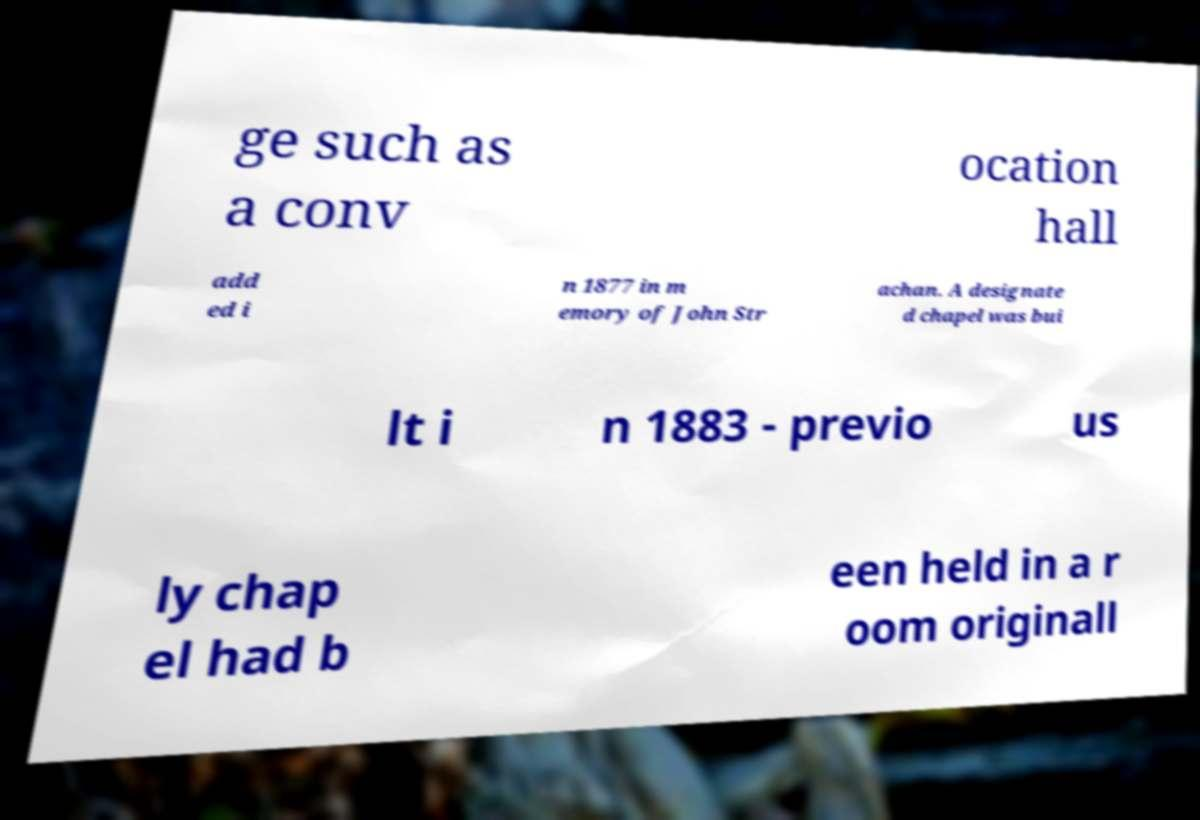There's text embedded in this image that I need extracted. Can you transcribe it verbatim? ge such as a conv ocation hall add ed i n 1877 in m emory of John Str achan. A designate d chapel was bui lt i n 1883 - previo us ly chap el had b een held in a r oom originall 